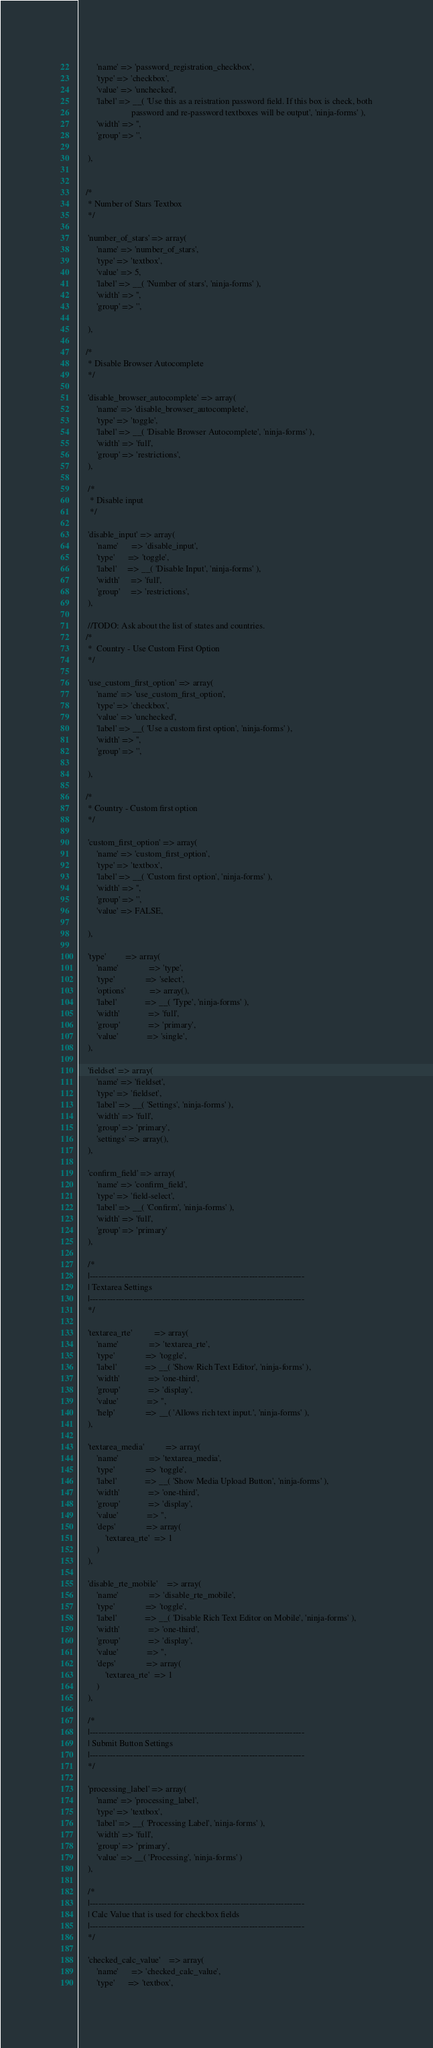<code> <loc_0><loc_0><loc_500><loc_500><_PHP_>        'name' => 'password_registration_checkbox',
        'type' => 'checkbox',
        'value' => 'unchecked',
        'label' => __( 'Use this as a reistration password field. If this box is check, both
                        password and re-password textboxes will be output', 'ninja-forms' ),
        'width' => '',
        'group' => '',

    ),


   /*
    * Number of Stars Textbox
    */

    'number_of_stars' => array(
        'name' => 'number_of_stars',
        'type' => 'textbox',
        'value' => 5,
        'label' => __( 'Number of stars', 'ninja-forms' ),
        'width' => '',
        'group' => '',

    ),

   /*
    * Disable Browser Autocomplete
    */

    'disable_browser_autocomplete' => array(
        'name' => 'disable_browser_autocomplete',
        'type' => 'toggle',
        'label' => __( 'Disable Browser Autocomplete', 'ninja-forms' ),
        'width' => 'full',
        'group' => 'restrictions',
    ),

    /*
     * Disable input
     */

    'disable_input' => array(
        'name'      => 'disable_input',
        'type'      => 'toggle',
        'label'     => __( 'Disable Input', 'ninja-forms' ),
        'width'     => 'full',
        'group'     => 'restrictions',
    ),

    //TODO: Ask about the list of states and countries.
   /*
    *  Country - Use Custom First Option
    */

    'use_custom_first_option' => array(
        'name' => 'use_custom_first_option',
        'type' => 'checkbox',
        'value' => 'unchecked',
        'label' => __( 'Use a custom first option', 'ninja-forms' ),
        'width' => '',
        'group' => '',

    ),

   /*
    * Country - Custom first option
    */

    'custom_first_option' => array(
        'name' => 'custom_first_option',
        'type' => 'textbox',
        'label' => __( 'Custom first option', 'ninja-forms' ),
        'width' => '',
        'group' => '',
        'value' => FALSE,

    ),

    'type'         => array(
        'name'              => 'type',
        'type'              => 'select',
        'options'           => array(),
        'label'             => __( 'Type', 'ninja-forms' ),
        'width'             => 'full',
        'group'             => 'primary',
        'value'             => 'single',
    ),

    'fieldset' => array(
        'name' => 'fieldset',
        'type' => 'fieldset',
        'label' => __( 'Settings', 'ninja-forms' ),
        'width' => 'full',
        'group' => 'primary',
        'settings' => array(),
    ),

    'confirm_field' => array(
        'name' => 'confirm_field',
        'type' => 'field-select',
        'label' => __( 'Confirm', 'ninja-forms' ),
        'width' => 'full',
        'group' => 'primary'
    ),

    /*
    |--------------------------------------------------------------------------
    | Textarea Settings
    |--------------------------------------------------------------------------
    */

    'textarea_rte'          => array(
        'name'              => 'textarea_rte',
        'type'              => 'toggle',
        'label'             => __( 'Show Rich Text Editor', 'ninja-forms' ),
        'width'             => 'one-third',
        'group'             => 'display',
        'value'             => '',
        'help'              => __( 'Allows rich text input.', 'ninja-forms' ),
    ),

    'textarea_media'          => array(
        'name'              => 'textarea_media',
        'type'              => 'toggle',
        'label'             => __( 'Show Media Upload Button', 'ninja-forms' ),
        'width'             => 'one-third',
        'group'             => 'display',
        'value'             => '',
        'deps'              => array(
            'textarea_rte'  => 1
        )
    ),

    'disable_rte_mobile'    => array(
        'name'              => 'disable_rte_mobile',
        'type'              => 'toggle',
        'label'             => __( 'Disable Rich Text Editor on Mobile', 'ninja-forms' ),
        'width'             => 'one-third',
        'group'             => 'display',
        'value'             => '',
        'deps'              => array(
            'textarea_rte'  => 1
        )
    ),

    /*
    |--------------------------------------------------------------------------
    | Submit Button Settings
    |--------------------------------------------------------------------------
    */

    'processing_label' => array(
        'name' => 'processing_label',
        'type' => 'textbox',
        'label' => __( 'Processing Label', 'ninja-forms' ),
        'width' => 'full',
        'group' => 'primary',
        'value' => __( 'Processing', 'ninja-forms' )
    ),

    /*
    |--------------------------------------------------------------------------
    | Calc Value that is used for checkbox fields
    |--------------------------------------------------------------------------
    */

    'checked_calc_value'    => array(
        'name'      => 'checked_calc_value',
        'type'      => 'textbox',</code> 